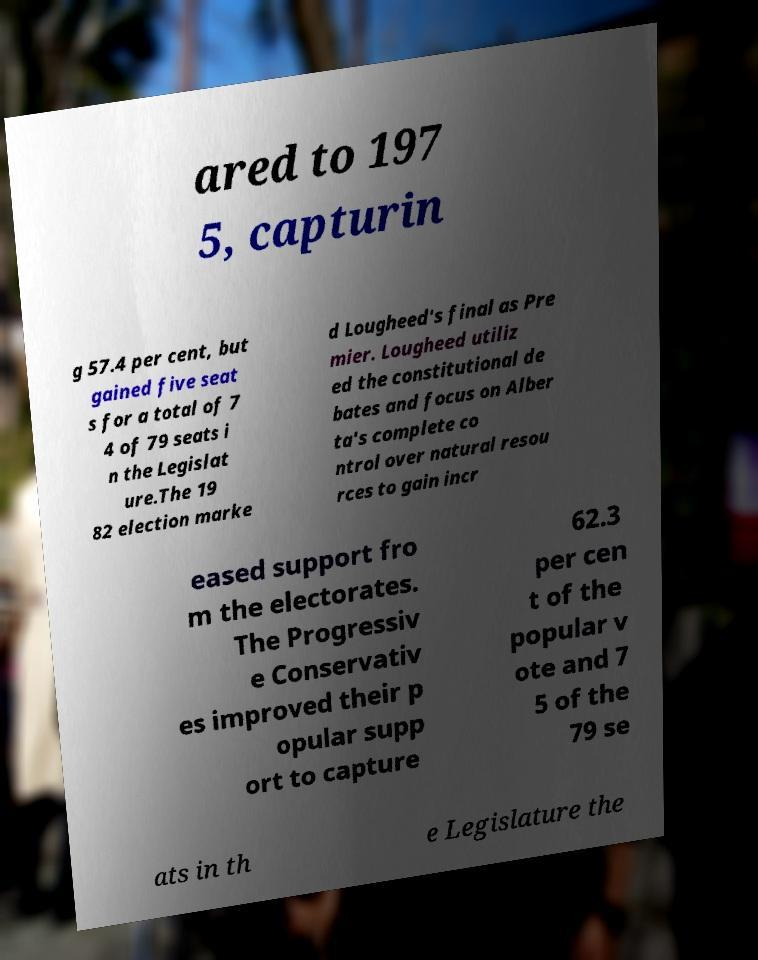I need the written content from this picture converted into text. Can you do that? ared to 197 5, capturin g 57.4 per cent, but gained five seat s for a total of 7 4 of 79 seats i n the Legislat ure.The 19 82 election marke d Lougheed's final as Pre mier. Lougheed utiliz ed the constitutional de bates and focus on Alber ta's complete co ntrol over natural resou rces to gain incr eased support fro m the electorates. The Progressiv e Conservativ es improved their p opular supp ort to capture 62.3 per cen t of the popular v ote and 7 5 of the 79 se ats in th e Legislature the 